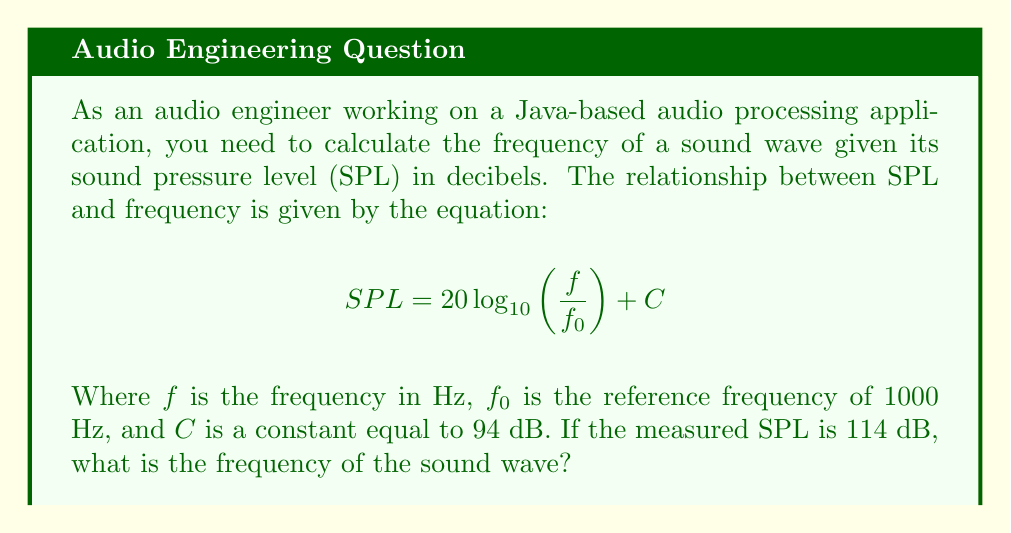Can you solve this math problem? Let's solve this step-by-step:

1) We start with the given equation:
   $$ SPL = 20 \log_{10}\left(\frac{f}{f_0}\right) + C $$

2) We know that:
   - $SPL = 114$ dB
   - $f_0 = 1000$ Hz
   - $C = 94$ dB

3) Let's substitute these values:
   $$ 114 = 20 \log_{10}\left(\frac{f}{1000}\right) + 94 $$

4) Subtract 94 from both sides:
   $$ 20 = 20 \log_{10}\left(\frac{f}{1000}\right) $$

5) Divide both sides by 20:
   $$ 1 = \log_{10}\left(\frac{f}{1000}\right) $$

6) Now, we can apply the inverse function (10 to the power) to both sides:
   $$ 10^1 = \frac{f}{1000} $$

7) Simplify:
   $$ 10 = \frac{f}{1000} $$

8) Multiply both sides by 1000:
   $$ 10000 = f $$

Therefore, the frequency of the sound wave is 10000 Hz or 10 kHz.
Answer: $f = 10000$ Hz 